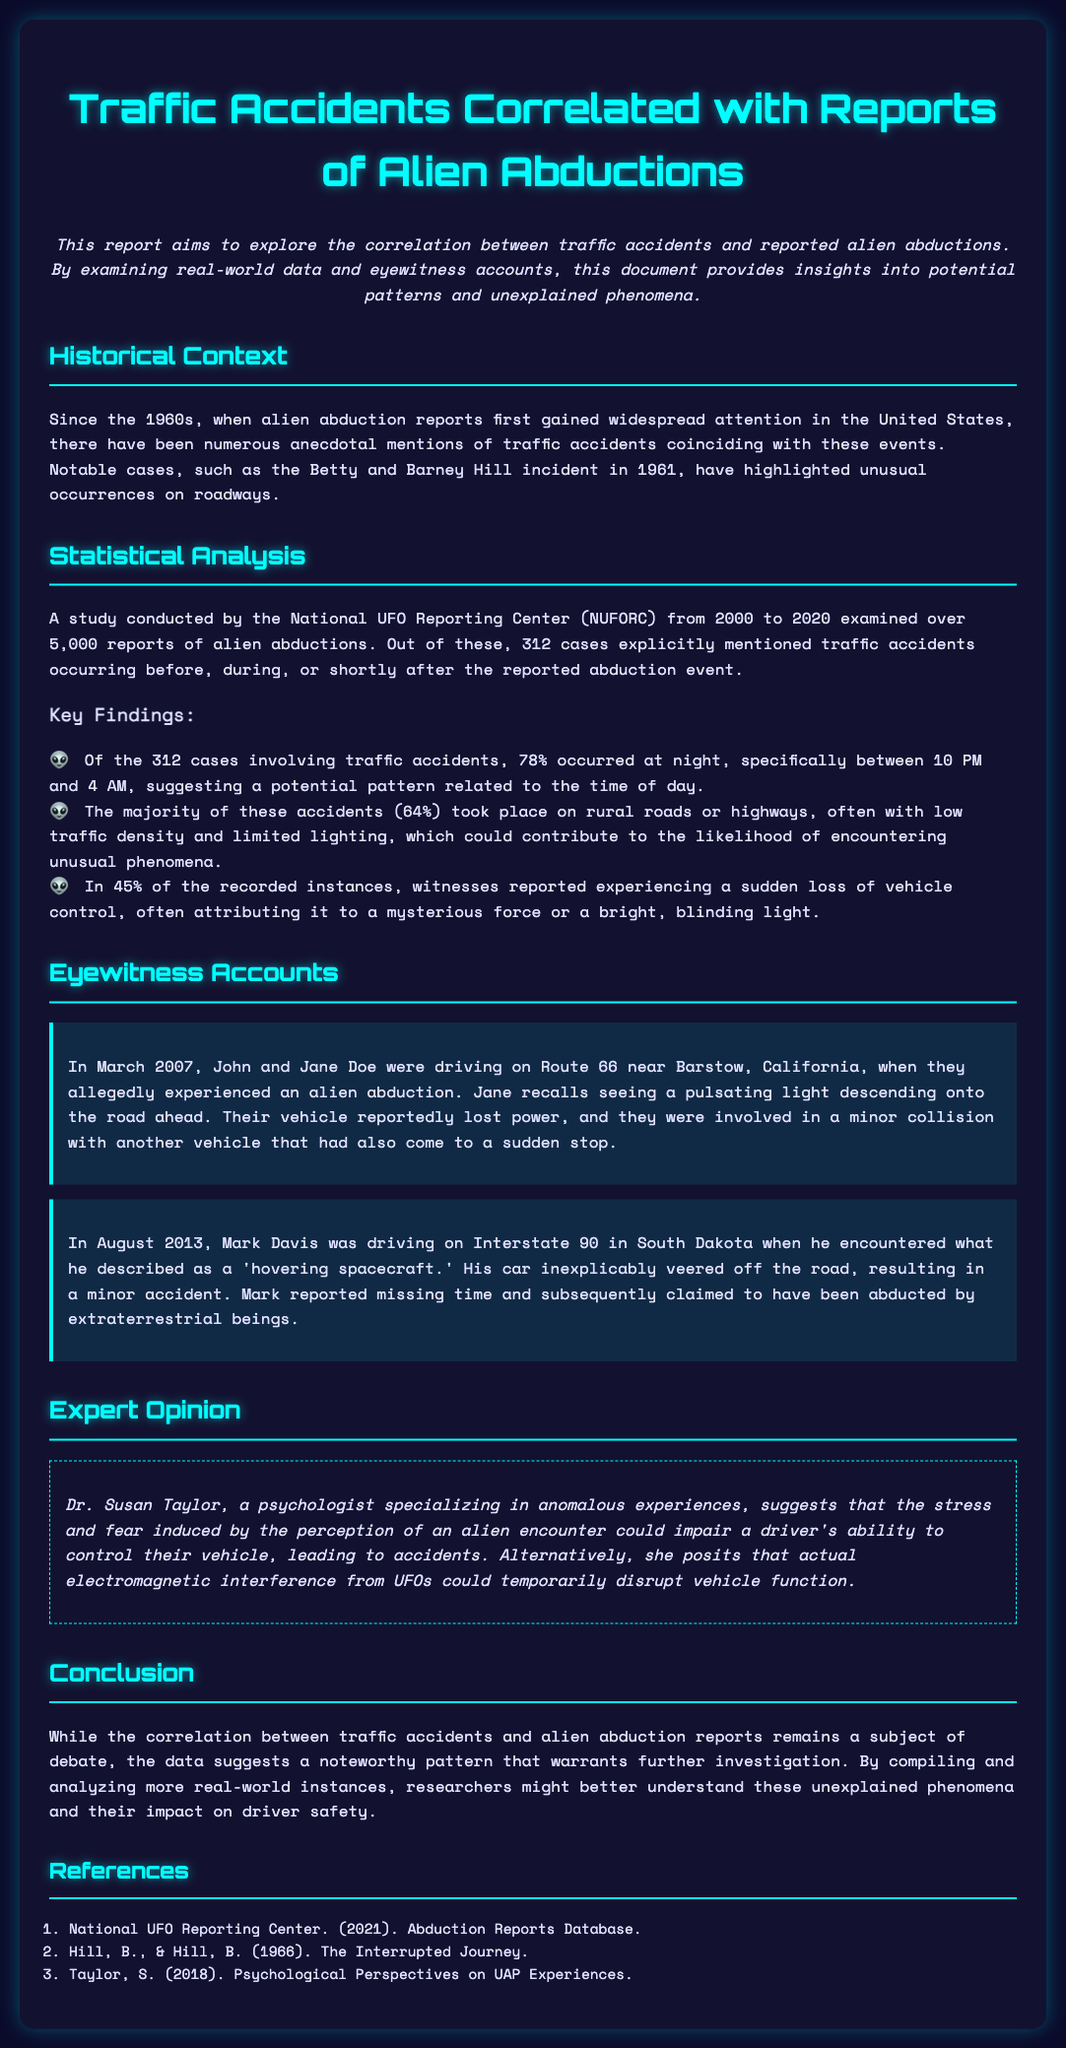what is the title of the report? The title of the report is mentioned at the beginning of the document, which is "Traffic Accidents Correlated with Reports of Alien Abductions."
Answer: Traffic Accidents Correlated with Reports of Alien Abductions how many cases mention traffic accidents? The document states that out of over 5,000 reports, 312 cases explicitly mentioned traffic accidents.
Answer: 312 during which hours did most accidents occur? The report indicates that 78% of accidents occurred at night between 10 PM and 4 AM.
Answer: 10 PM and 4 AM what percentage of accidents happened on rural roads? The document mentions that 64% of the accidents took place on rural roads or highways.
Answer: 64% who provided an expert opinion in the report? The expert opinion in the report is provided by Dr. Susan Taylor, a psychologist specializing in anomalous experiences.
Answer: Dr. Susan Taylor what is suggested as a potential cause for loss of vehicle control? The report suggests that extreme stress and fear due to an alien encounter could impair a driver's capability.
Answer: stress and fear how many eyewitness accounts are featured in the report? The document features two eyewitness accounts that illustrate experiences related to alien abductions and traffic accidents.
Answer: two what time frame was analyzed by the National UFO Reporting Center? The time frame analyzed by NUFORC spans from 2000 to 2020.
Answer: 2000 to 2020 what type of document is this? The document provides insights and data analysis about the relationship between two specific phenomena: traffic accidents and reported alien encounters.
Answer: Traffic report 